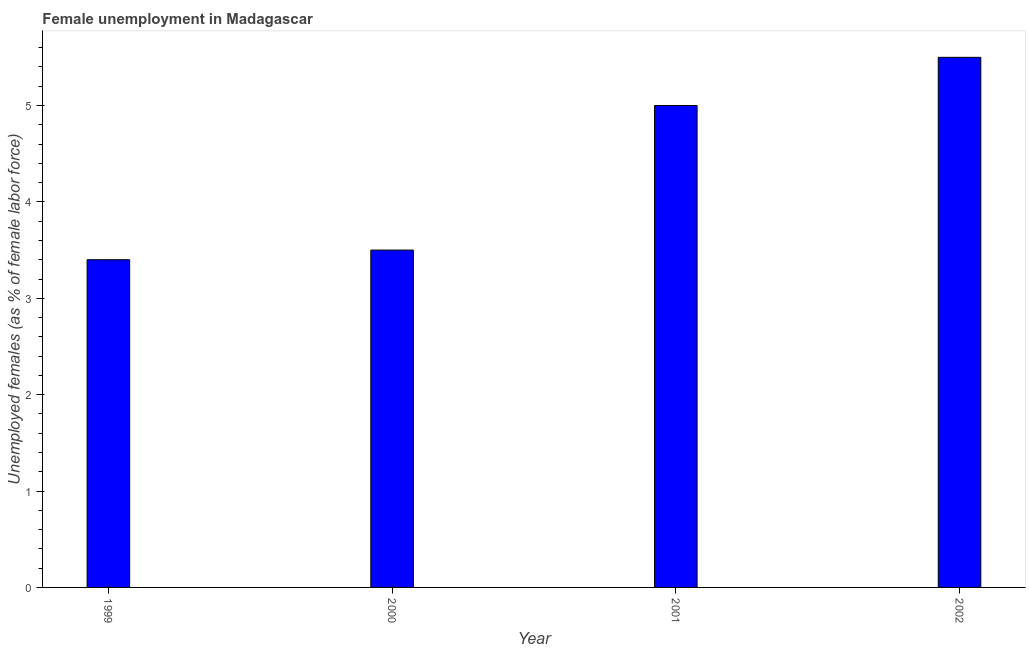Does the graph contain any zero values?
Give a very brief answer. No. Does the graph contain grids?
Provide a short and direct response. No. What is the title of the graph?
Offer a very short reply. Female unemployment in Madagascar. What is the label or title of the X-axis?
Your answer should be compact. Year. What is the label or title of the Y-axis?
Your response must be concise. Unemployed females (as % of female labor force). What is the unemployed females population in 2001?
Offer a very short reply. 5. Across all years, what is the maximum unemployed females population?
Make the answer very short. 5.5. Across all years, what is the minimum unemployed females population?
Give a very brief answer. 3.4. In which year was the unemployed females population minimum?
Provide a short and direct response. 1999. What is the sum of the unemployed females population?
Offer a terse response. 17.4. What is the average unemployed females population per year?
Make the answer very short. 4.35. What is the median unemployed females population?
Your answer should be compact. 4.25. In how many years, is the unemployed females population greater than 3 %?
Provide a short and direct response. 4. What is the ratio of the unemployed females population in 2000 to that in 2002?
Offer a very short reply. 0.64. Is the unemployed females population in 2000 less than that in 2002?
Your response must be concise. Yes. Is the difference between the unemployed females population in 2001 and 2002 greater than the difference between any two years?
Provide a short and direct response. No. What is the difference between the highest and the lowest unemployed females population?
Make the answer very short. 2.1. How many bars are there?
Your answer should be compact. 4. How many years are there in the graph?
Your answer should be very brief. 4. What is the Unemployed females (as % of female labor force) in 1999?
Your response must be concise. 3.4. What is the Unemployed females (as % of female labor force) of 2001?
Ensure brevity in your answer.  5. What is the difference between the Unemployed females (as % of female labor force) in 1999 and 2001?
Your answer should be very brief. -1.6. What is the difference between the Unemployed females (as % of female labor force) in 1999 and 2002?
Offer a terse response. -2.1. What is the difference between the Unemployed females (as % of female labor force) in 2000 and 2002?
Offer a very short reply. -2. What is the ratio of the Unemployed females (as % of female labor force) in 1999 to that in 2000?
Your answer should be very brief. 0.97. What is the ratio of the Unemployed females (as % of female labor force) in 1999 to that in 2001?
Your answer should be very brief. 0.68. What is the ratio of the Unemployed females (as % of female labor force) in 1999 to that in 2002?
Provide a succinct answer. 0.62. What is the ratio of the Unemployed females (as % of female labor force) in 2000 to that in 2002?
Ensure brevity in your answer.  0.64. What is the ratio of the Unemployed females (as % of female labor force) in 2001 to that in 2002?
Your answer should be compact. 0.91. 